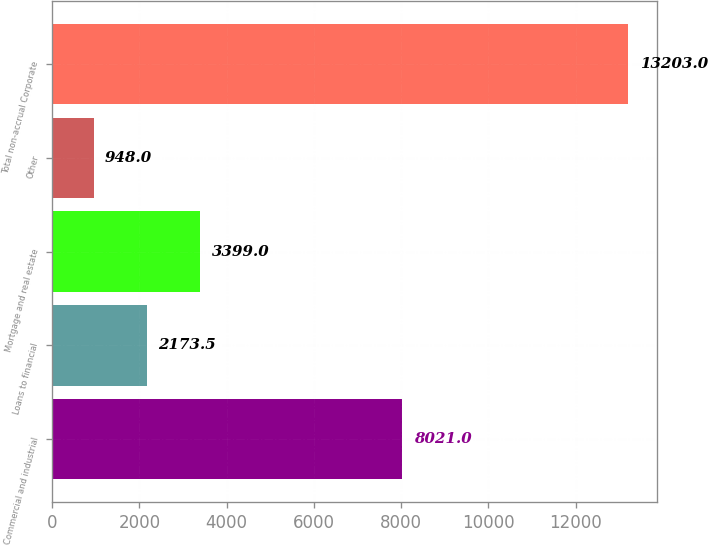<chart> <loc_0><loc_0><loc_500><loc_500><bar_chart><fcel>Commercial and industrial<fcel>Loans to financial<fcel>Mortgage and real estate<fcel>Other<fcel>Total non-accrual Corporate<nl><fcel>8021<fcel>2173.5<fcel>3399<fcel>948<fcel>13203<nl></chart> 